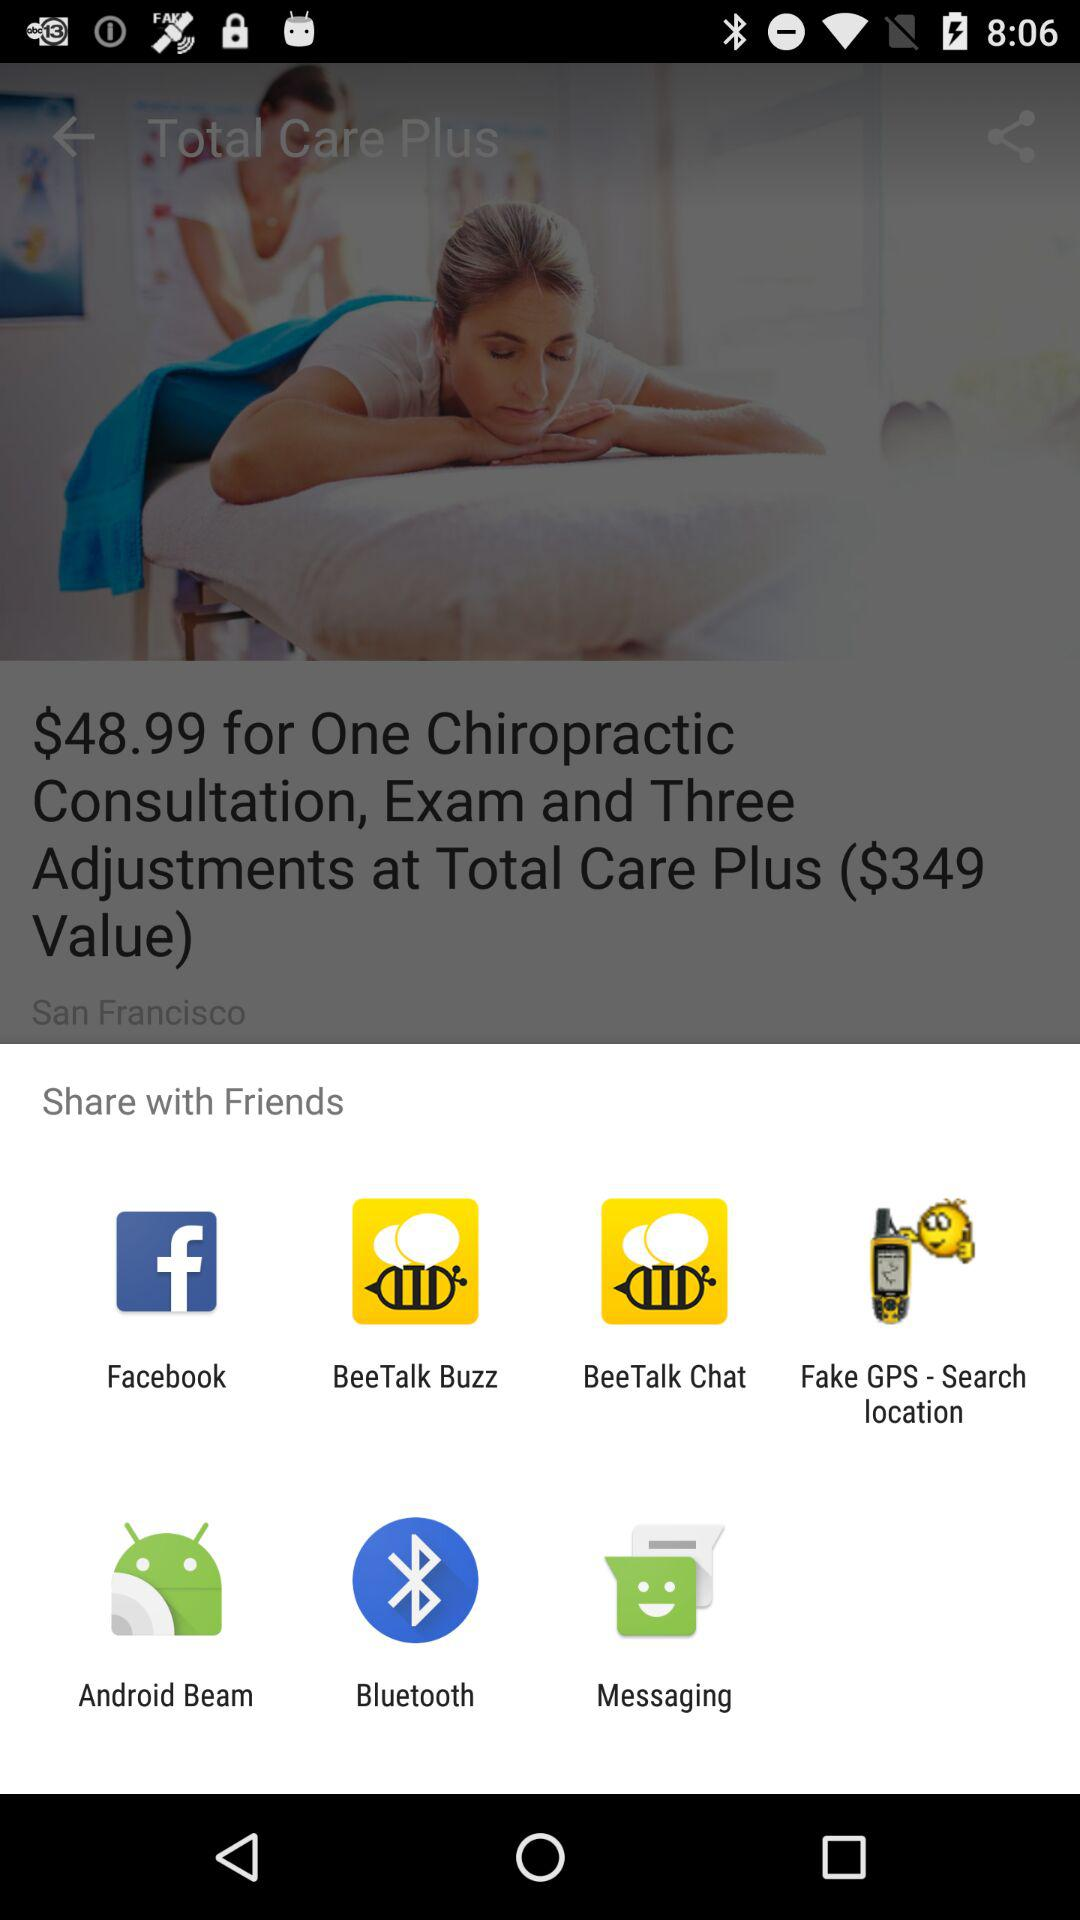Through what application can we share it with? We can share it through "Facebook", "BeeTalk Buzz", "BeeTalk Chat", "Fake GPS-Search location", "Android Beam", "Bluetooth", and "Messaging". 